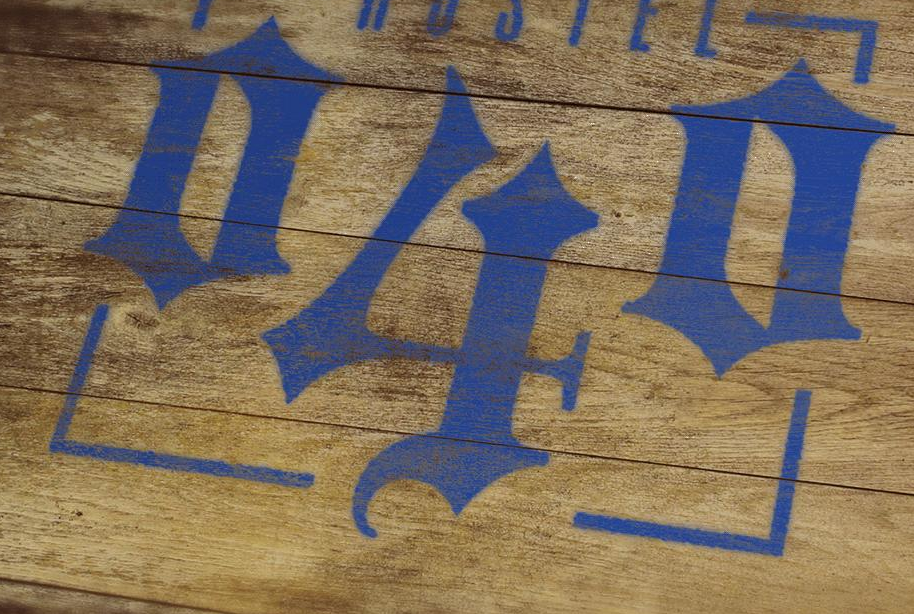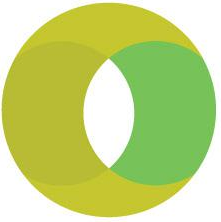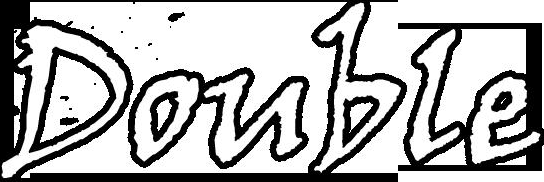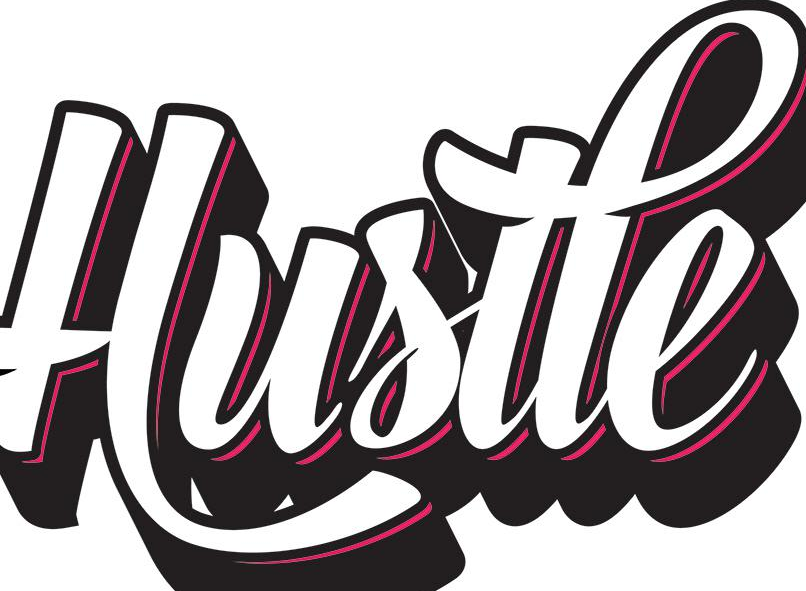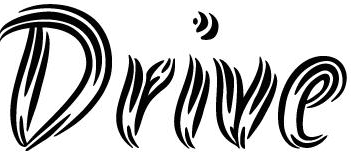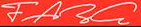What words can you see in these images in sequence, separated by a semicolon? 040; O; Double; Hustle; Drive; FARG 